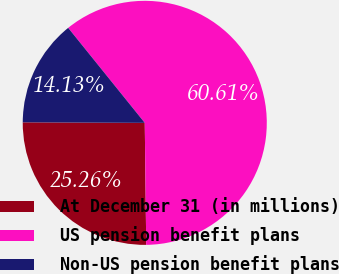<chart> <loc_0><loc_0><loc_500><loc_500><pie_chart><fcel>At December 31 (in millions)<fcel>US pension benefit plans<fcel>Non-US pension benefit plans<nl><fcel>25.26%<fcel>60.61%<fcel>14.13%<nl></chart> 